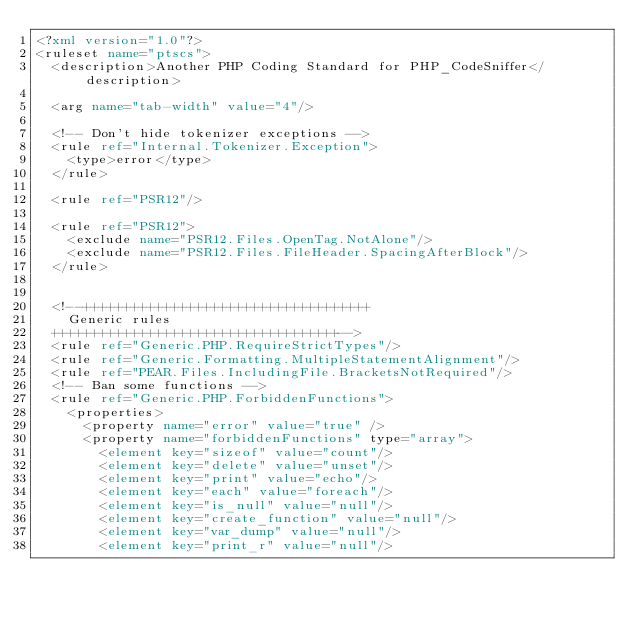Convert code to text. <code><loc_0><loc_0><loc_500><loc_500><_XML_><?xml version="1.0"?>
<ruleset name="ptscs">
  <description>Another PHP Coding Standard for PHP_CodeSniffer</description>

  <arg name="tab-width" value="4"/>

  <!-- Don't hide tokenizer exceptions -->
  <rule ref="Internal.Tokenizer.Exception">
    <type>error</type>
  </rule>

  <rule ref="PSR12"/>

  <rule ref="PSR12">
    <exclude name="PSR12.Files.OpenTag.NotAlone"/>
    <exclude name="PSR12.Files.FileHeader.SpacingAfterBlock"/>
  </rule>


  <!--++++++++++++++++++++++++++++++++++++
    Generic rules
  ++++++++++++++++++++++++++++++++++++-->
  <rule ref="Generic.PHP.RequireStrictTypes"/>
  <rule ref="Generic.Formatting.MultipleStatementAlignment"/>
  <rule ref="PEAR.Files.IncludingFile.BracketsNotRequired"/>
  <!-- Ban some functions -->
  <rule ref="Generic.PHP.ForbiddenFunctions">
    <properties>
      <property name="error" value="true" />
      <property name="forbiddenFunctions" type="array">
        <element key="sizeof" value="count"/>
        <element key="delete" value="unset"/>
        <element key="print" value="echo"/>
        <element key="each" value="foreach"/>
        <element key="is_null" value="null"/>
        <element key="create_function" value="null"/>
        <element key="var_dump" value="null"/>
        <element key="print_r" value="null"/></code> 